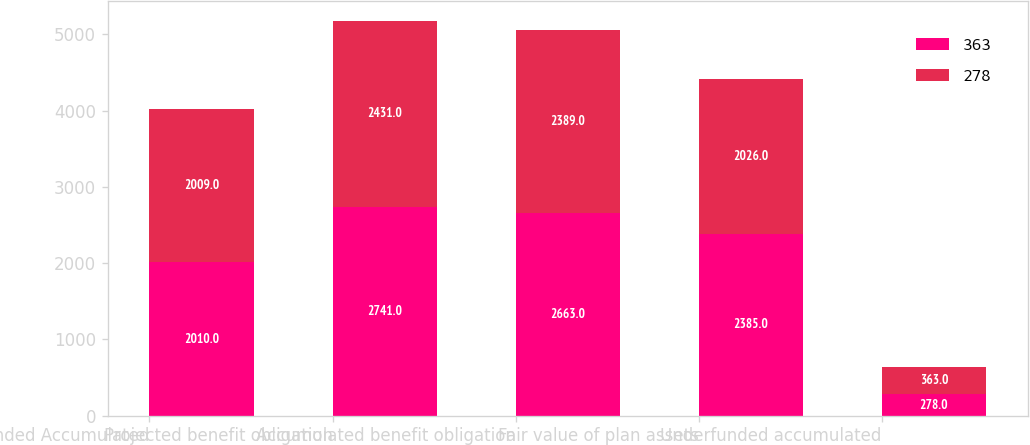Convert chart. <chart><loc_0><loc_0><loc_500><loc_500><stacked_bar_chart><ecel><fcel>Underfunded Accumulated<fcel>Projected benefit obligation<fcel>Accumulated benefit obligation<fcel>Fair value of plan assets<fcel>Underfunded accumulated<nl><fcel>363<fcel>2010<fcel>2741<fcel>2663<fcel>2385<fcel>278<nl><fcel>278<fcel>2009<fcel>2431<fcel>2389<fcel>2026<fcel>363<nl></chart> 